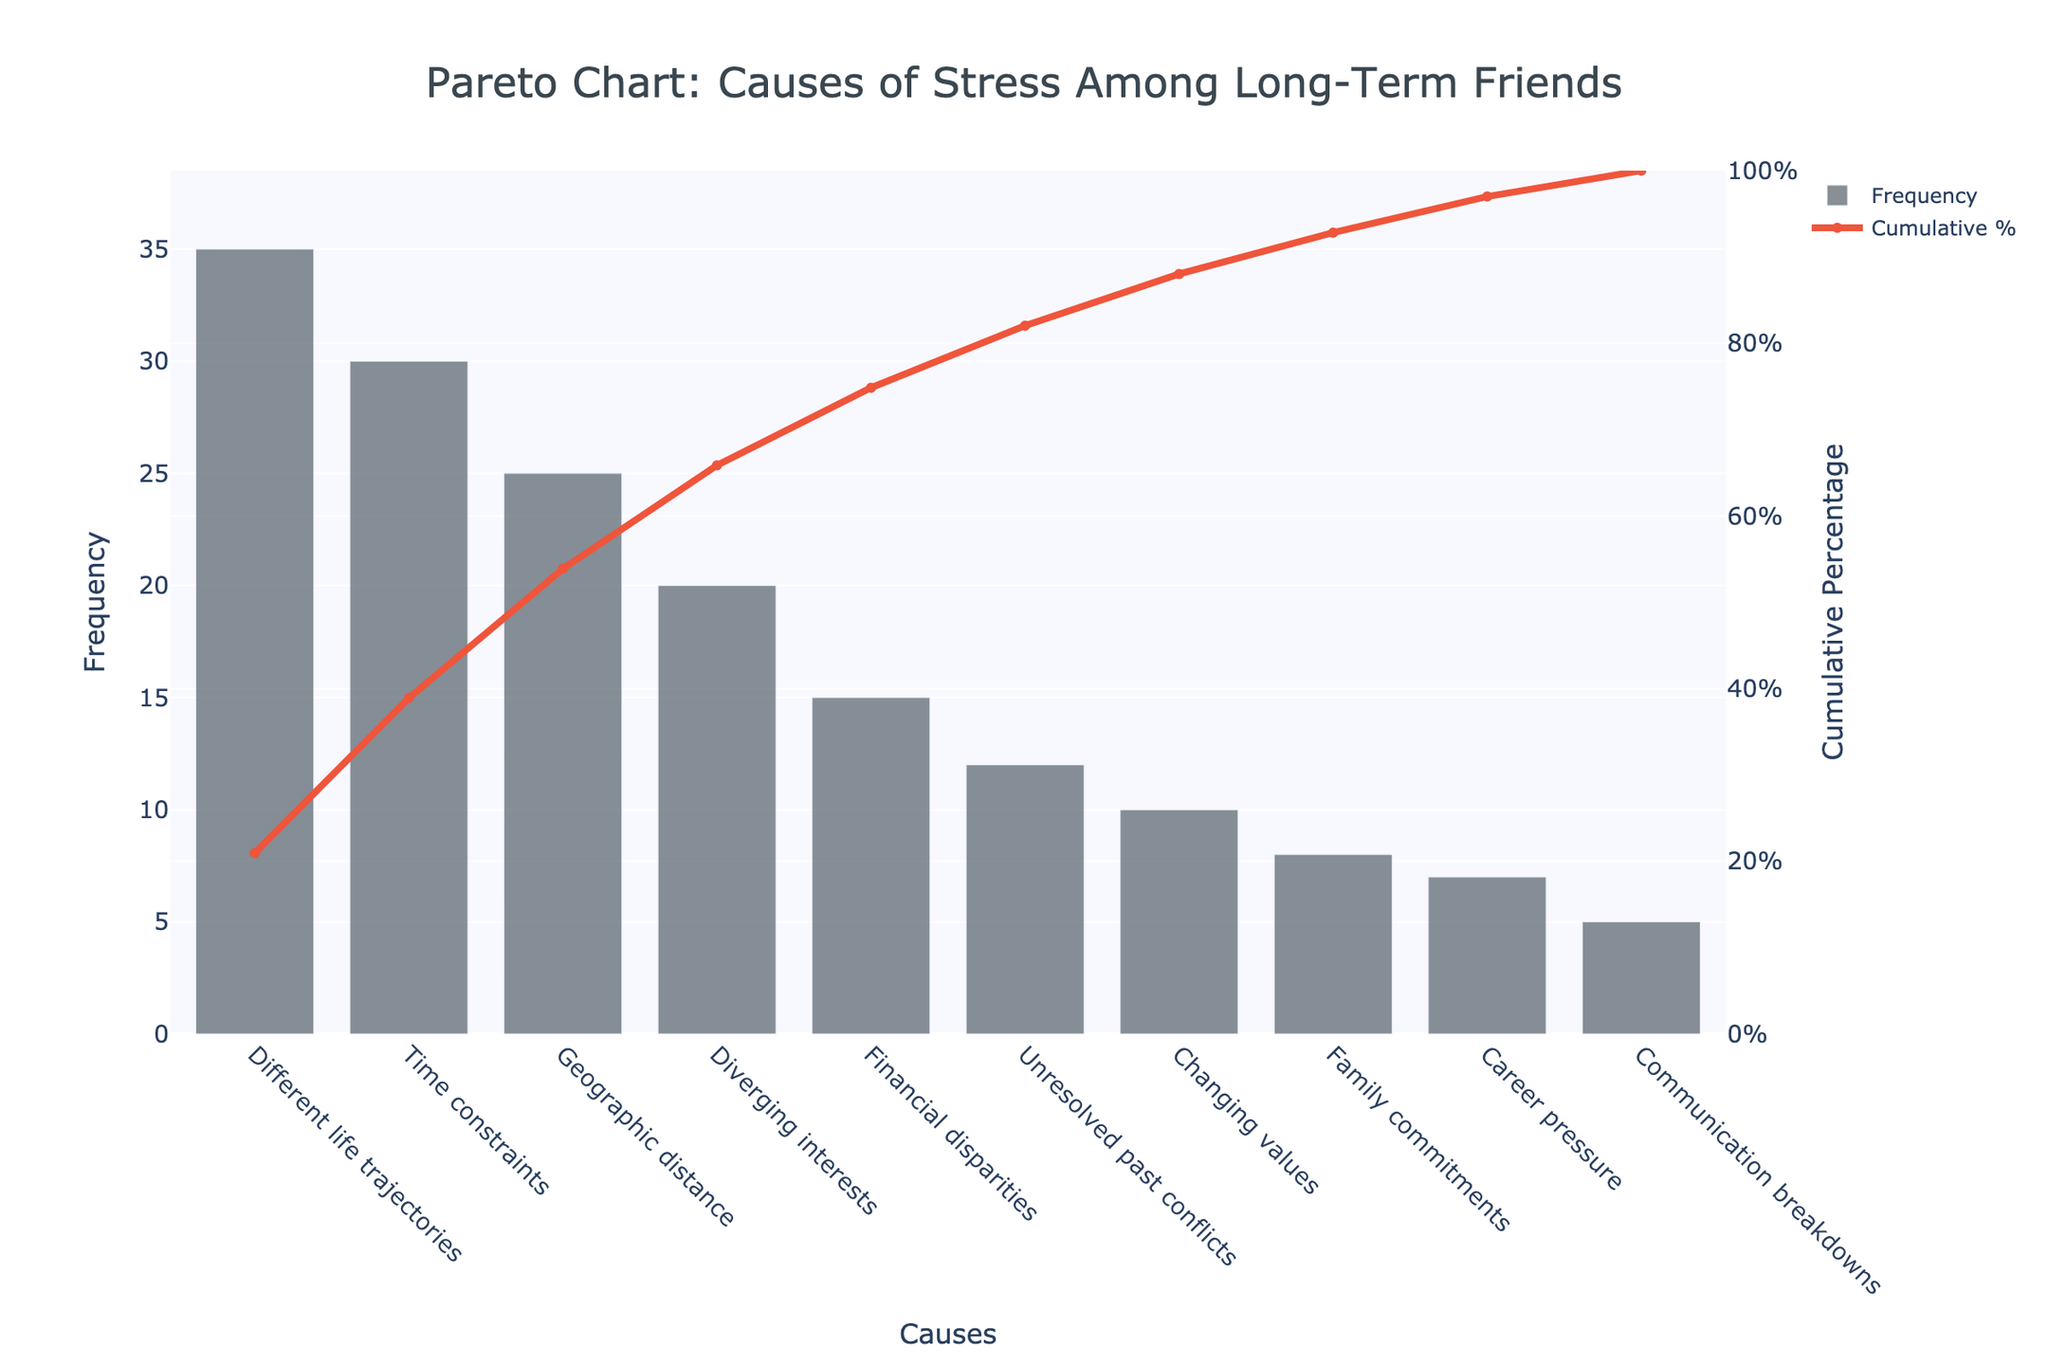What is the most frequent cause of stress among long-term friends? The most frequent cause of stress is the one with the highest bar on the chart. "Different life trajectories" has the highest frequency of 35.
Answer: Different life trajectories What percentage of the total frequency is due to 'Time constraints' and 'Geographic distance'? To find the percentage, sum the frequencies of 'Time constraints' (30) and 'Geographic distance' (25), which is 55. Then, divide by the total frequency sum (167) and multiply by 100. Therefore, (55/167) * 100 = 32.93%.
Answer: 32.93% Which cause of stress has the lowest frequency? The lowest frequency is represented by the smallest bar on the chart. 'Communication breakdowns' has the lowest frequency with 5.
Answer: Communication breakdowns What is the cumulative percentage of causes once 'Diverging interests' is included? The cumulative percentage up to and including 'Diverging interests' can be directly read from the cumulative line plotted on the secondary y-axis. It shows 60% for 'Diverging interests'.
Answer: 60% How many causes of stress have a frequency greater than 10? By counting the bars with a height greater than 10, we can see there are 6: 'Different life trajectories', 'Time constraints', 'Geographic distance', 'Diverging interests', 'Financial disparities', and 'Unresolved past conflicts'.
Answer: 6 Between 'Changing values' and 'Family commitments', which cause has a higher impact and by how much? 'Changing values' has a frequency of 10, while 'Family commitments' has a frequency of 8. The difference is 10 - 8 = 2. Therefore, 'Changing values' has a higher impact by 2.
Answer: 2 What is the total frequency of all the causes of stress listed? Adding up all given frequencies: 35 + 30 + 25 + 20 + 15 + 12 + 10 + 8 + 7 + 5 = 167.
Answer: 167 Which cause of stress has the highest cumulative impact after 'Financial disparities'? Looking at the cumulative percentages up to 'Financial disparities', the highest cumulative impact after it is 'Unresolved past conflicts' with a cumulative percentage of 60% and a frequency of 12.
Answer: Unresolved past conflicts What is the cumulative percentage for the least frequent four causes combined? The cumulative percentage for the least frequent four causes ('Family commitments', 'Career pressure', 'Communication breakdowns') can be read from the cumulative line on each cause's bar: 40% for 'Family commitments', and the rest can be visually estimated or read as 35% for 'Career pressure' and 25% for 'Communication breakdowns'. Summing these up: (40+35+25), correcting for correct overlap if necessary.
Answer: Approximately 24.46% Which two causes of stress contribute to approximately 50% of the cumulative percentage? By looking at the cumulative percentage values, 'Different life trajectories' and 'Time constraints' together reach a cumulative percentage of 50% (35% + 30% frequency values respectively).
Answer: Different life trajectories, Time constraints 